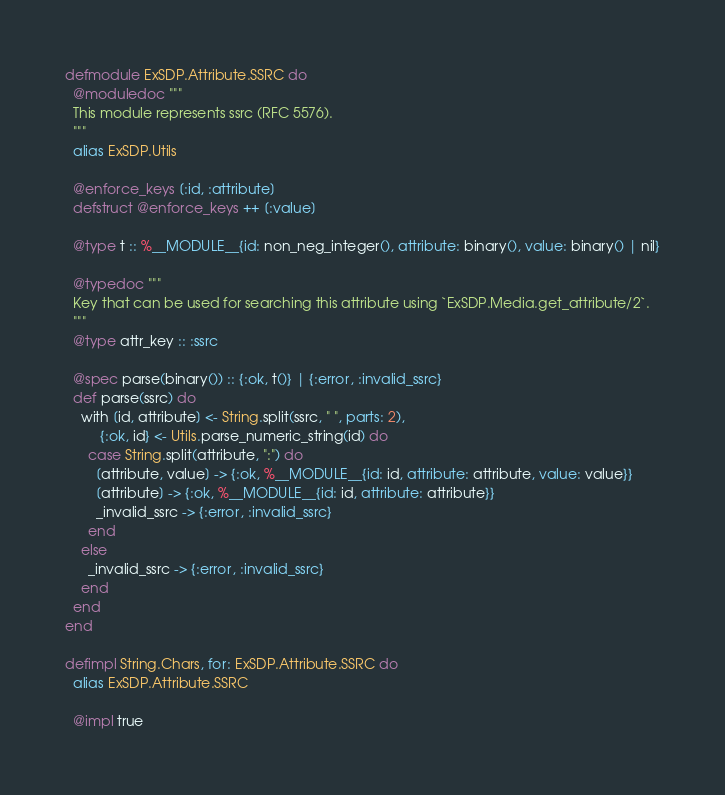<code> <loc_0><loc_0><loc_500><loc_500><_Elixir_>defmodule ExSDP.Attribute.SSRC do
  @moduledoc """
  This module represents ssrc (RFC 5576).
  """
  alias ExSDP.Utils

  @enforce_keys [:id, :attribute]
  defstruct @enforce_keys ++ [:value]

  @type t :: %__MODULE__{id: non_neg_integer(), attribute: binary(), value: binary() | nil}

  @typedoc """
  Key that can be used for searching this attribute using `ExSDP.Media.get_attribute/2`.
  """
  @type attr_key :: :ssrc

  @spec parse(binary()) :: {:ok, t()} | {:error, :invalid_ssrc}
  def parse(ssrc) do
    with [id, attribute] <- String.split(ssrc, " ", parts: 2),
         {:ok, id} <- Utils.parse_numeric_string(id) do
      case String.split(attribute, ":") do
        [attribute, value] -> {:ok, %__MODULE__{id: id, attribute: attribute, value: value}}
        [attribute] -> {:ok, %__MODULE__{id: id, attribute: attribute}}
        _invalid_ssrc -> {:error, :invalid_ssrc}
      end
    else
      _invalid_ssrc -> {:error, :invalid_ssrc}
    end
  end
end

defimpl String.Chars, for: ExSDP.Attribute.SSRC do
  alias ExSDP.Attribute.SSRC

  @impl true</code> 